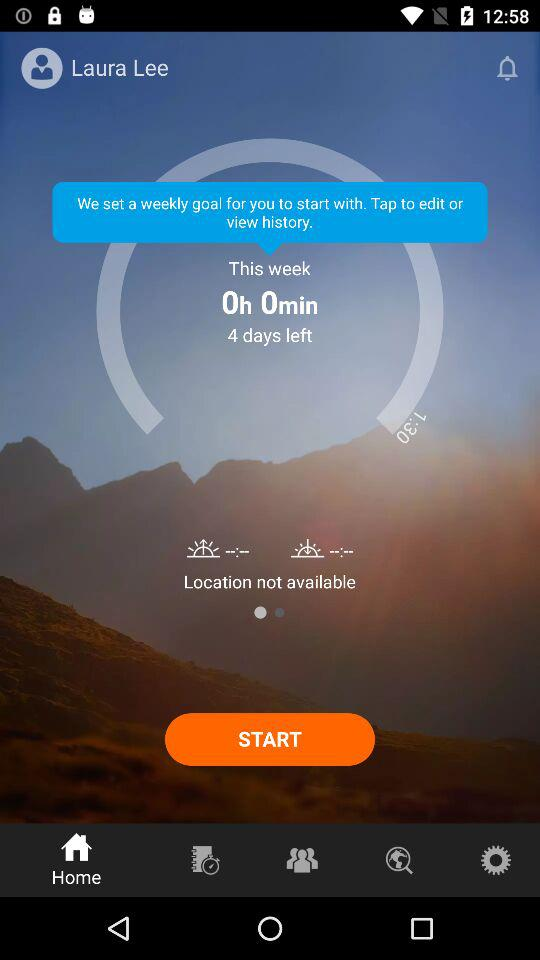How much time was spent this week? The time spent this week was 0 hours and 0 minutes. 